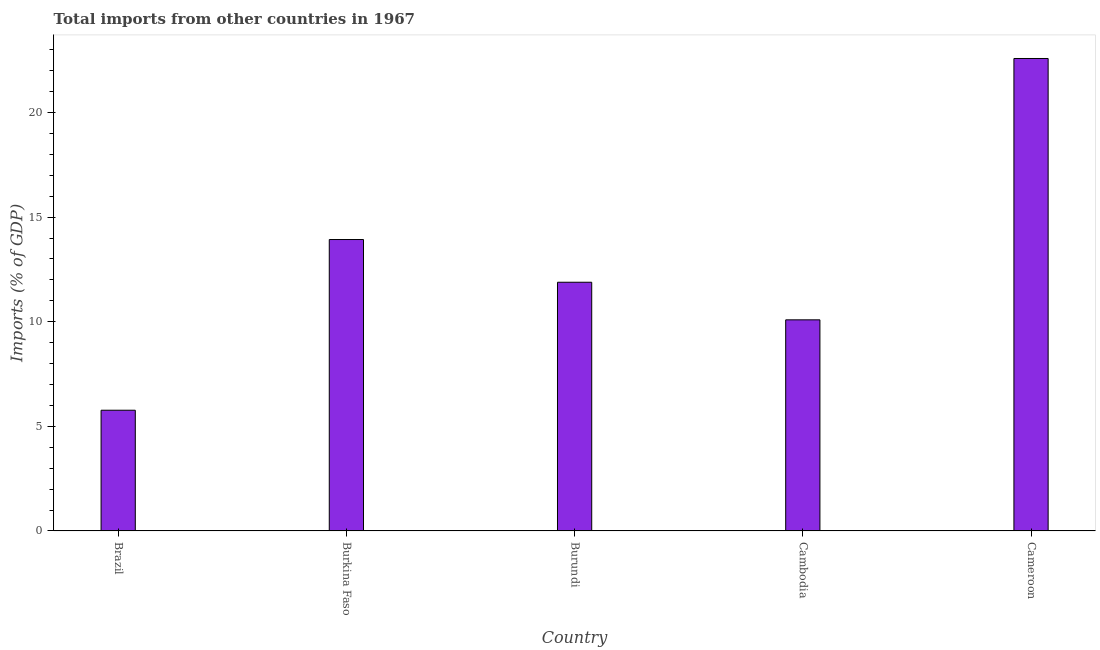Does the graph contain any zero values?
Your answer should be compact. No. Does the graph contain grids?
Your response must be concise. No. What is the title of the graph?
Your answer should be very brief. Total imports from other countries in 1967. What is the label or title of the X-axis?
Your answer should be compact. Country. What is the label or title of the Y-axis?
Your answer should be very brief. Imports (% of GDP). What is the total imports in Brazil?
Your answer should be compact. 5.77. Across all countries, what is the maximum total imports?
Your answer should be very brief. 22.58. Across all countries, what is the minimum total imports?
Your response must be concise. 5.77. In which country was the total imports maximum?
Your answer should be very brief. Cameroon. In which country was the total imports minimum?
Offer a very short reply. Brazil. What is the sum of the total imports?
Provide a short and direct response. 64.25. What is the difference between the total imports in Brazil and Cambodia?
Your response must be concise. -4.32. What is the average total imports per country?
Provide a succinct answer. 12.85. What is the median total imports?
Offer a terse response. 11.89. What is the ratio of the total imports in Burkina Faso to that in Cambodia?
Provide a short and direct response. 1.38. Is the difference between the total imports in Burkina Faso and Cambodia greater than the difference between any two countries?
Your answer should be compact. No. What is the difference between the highest and the second highest total imports?
Provide a succinct answer. 8.65. Is the sum of the total imports in Brazil and Cambodia greater than the maximum total imports across all countries?
Your answer should be very brief. No. What is the difference between the highest and the lowest total imports?
Give a very brief answer. 16.81. How many bars are there?
Offer a very short reply. 5. What is the difference between two consecutive major ticks on the Y-axis?
Make the answer very short. 5. Are the values on the major ticks of Y-axis written in scientific E-notation?
Your answer should be very brief. No. What is the Imports (% of GDP) of Brazil?
Give a very brief answer. 5.77. What is the Imports (% of GDP) of Burkina Faso?
Ensure brevity in your answer.  13.93. What is the Imports (% of GDP) of Burundi?
Your response must be concise. 11.89. What is the Imports (% of GDP) in Cambodia?
Provide a short and direct response. 10.09. What is the Imports (% of GDP) of Cameroon?
Make the answer very short. 22.58. What is the difference between the Imports (% of GDP) in Brazil and Burkina Faso?
Offer a very short reply. -8.16. What is the difference between the Imports (% of GDP) in Brazil and Burundi?
Offer a very short reply. -6.12. What is the difference between the Imports (% of GDP) in Brazil and Cambodia?
Give a very brief answer. -4.32. What is the difference between the Imports (% of GDP) in Brazil and Cameroon?
Offer a terse response. -16.81. What is the difference between the Imports (% of GDP) in Burkina Faso and Burundi?
Offer a very short reply. 2.04. What is the difference between the Imports (% of GDP) in Burkina Faso and Cambodia?
Provide a short and direct response. 3.84. What is the difference between the Imports (% of GDP) in Burkina Faso and Cameroon?
Ensure brevity in your answer.  -8.65. What is the difference between the Imports (% of GDP) in Burundi and Cambodia?
Provide a short and direct response. 1.8. What is the difference between the Imports (% of GDP) in Burundi and Cameroon?
Ensure brevity in your answer.  -10.69. What is the difference between the Imports (% of GDP) in Cambodia and Cameroon?
Offer a very short reply. -12.49. What is the ratio of the Imports (% of GDP) in Brazil to that in Burkina Faso?
Your answer should be very brief. 0.41. What is the ratio of the Imports (% of GDP) in Brazil to that in Burundi?
Your response must be concise. 0.48. What is the ratio of the Imports (% of GDP) in Brazil to that in Cambodia?
Your answer should be very brief. 0.57. What is the ratio of the Imports (% of GDP) in Brazil to that in Cameroon?
Provide a short and direct response. 0.26. What is the ratio of the Imports (% of GDP) in Burkina Faso to that in Burundi?
Provide a short and direct response. 1.17. What is the ratio of the Imports (% of GDP) in Burkina Faso to that in Cambodia?
Your answer should be compact. 1.38. What is the ratio of the Imports (% of GDP) in Burkina Faso to that in Cameroon?
Provide a succinct answer. 0.62. What is the ratio of the Imports (% of GDP) in Burundi to that in Cambodia?
Your response must be concise. 1.18. What is the ratio of the Imports (% of GDP) in Burundi to that in Cameroon?
Provide a short and direct response. 0.53. What is the ratio of the Imports (% of GDP) in Cambodia to that in Cameroon?
Offer a terse response. 0.45. 